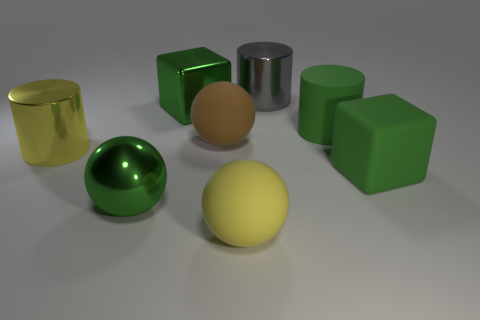How many green cubes must be subtracted to get 1 green cubes? 1 Subtract all large yellow cylinders. How many cylinders are left? 2 Add 2 large green matte cylinders. How many objects exist? 10 Subtract all gray cylinders. How many cylinders are left? 2 Subtract all spheres. How many objects are left? 5 Subtract 2 balls. How many balls are left? 1 Subtract 0 purple blocks. How many objects are left? 8 Subtract all yellow cubes. Subtract all gray cylinders. How many cubes are left? 2 Subtract all red balls. How many yellow cylinders are left? 1 Subtract all small brown matte things. Subtract all large green matte cylinders. How many objects are left? 7 